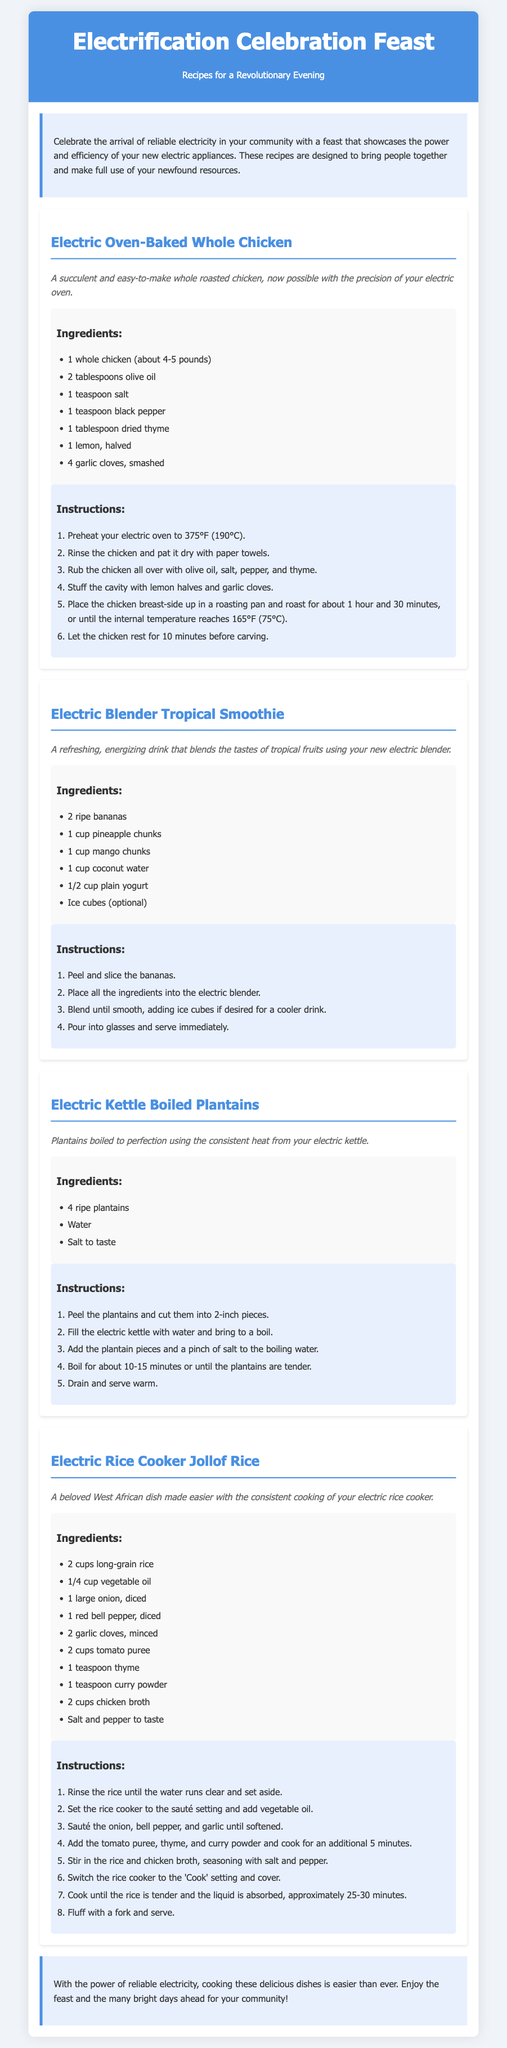What is the title of the document? The title appears prominently at the top of the document under the header section.
Answer: Electrification Celebration Feast How many recipes are included in the document? The document contains a section for each recipe, indicating there are four distinct recipes presented.
Answer: 4 What is the first recipe listed? The recipe is identified by its heading at the start of its dedicated section.
Answer: Electric Oven-Baked Whole Chicken What is the cooking time for the electric oven-baked whole chicken? The cooking time is mentioned in the instructions for that recipe.
Answer: 1 hour and 30 minutes Which appliance is used for making the tropical smoothie? The specific appliance is referred to in the description of the corresponding recipe.
Answer: Electric blender What are the main ingredients for the Jollof rice? The main ingredients are listed under the ingredients section for that specific recipe.
Answer: Long-grain rice, vegetable oil, onion, red bell pepper, garlic, tomato puree, thyme, curry powder, chicken broth, salt, pepper Which recipe requires boiling in an electric kettle? The recipe is identifiable from the title of its section in the document.
Answer: Electric Kettle Boiled Plantains What is the description of the tropical smoothie? The description is provided just below the title of that recipe.
Answer: A refreshing, energizing drink that blends the tastes of tropical fruits using your new electric blender 